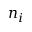<formula> <loc_0><loc_0><loc_500><loc_500>n _ { i }</formula> 